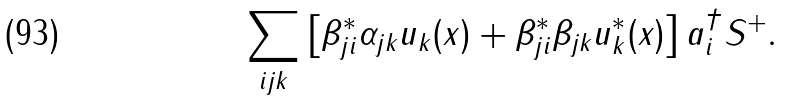Convert formula to latex. <formula><loc_0><loc_0><loc_500><loc_500>\sum _ { i j k } \left [ \beta ^ { * } _ { j i } \alpha _ { j k } u _ { k } ( x ) + \beta _ { j i } ^ { * } \beta _ { j k } u _ { k } ^ { * } ( x ) \right ] a _ { i } ^ { \dag } S ^ { + } .</formula> 